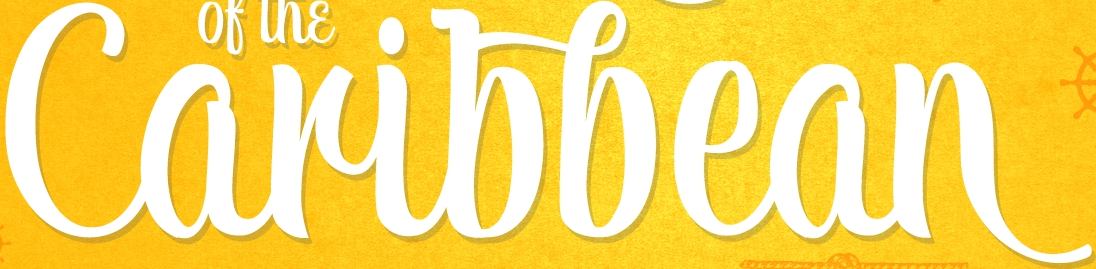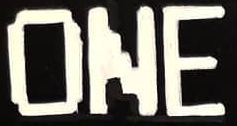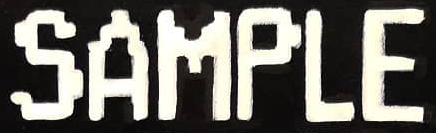What words can you see in these images in sequence, separated by a semicolon? Caribbean; ONE; SAMPLE 